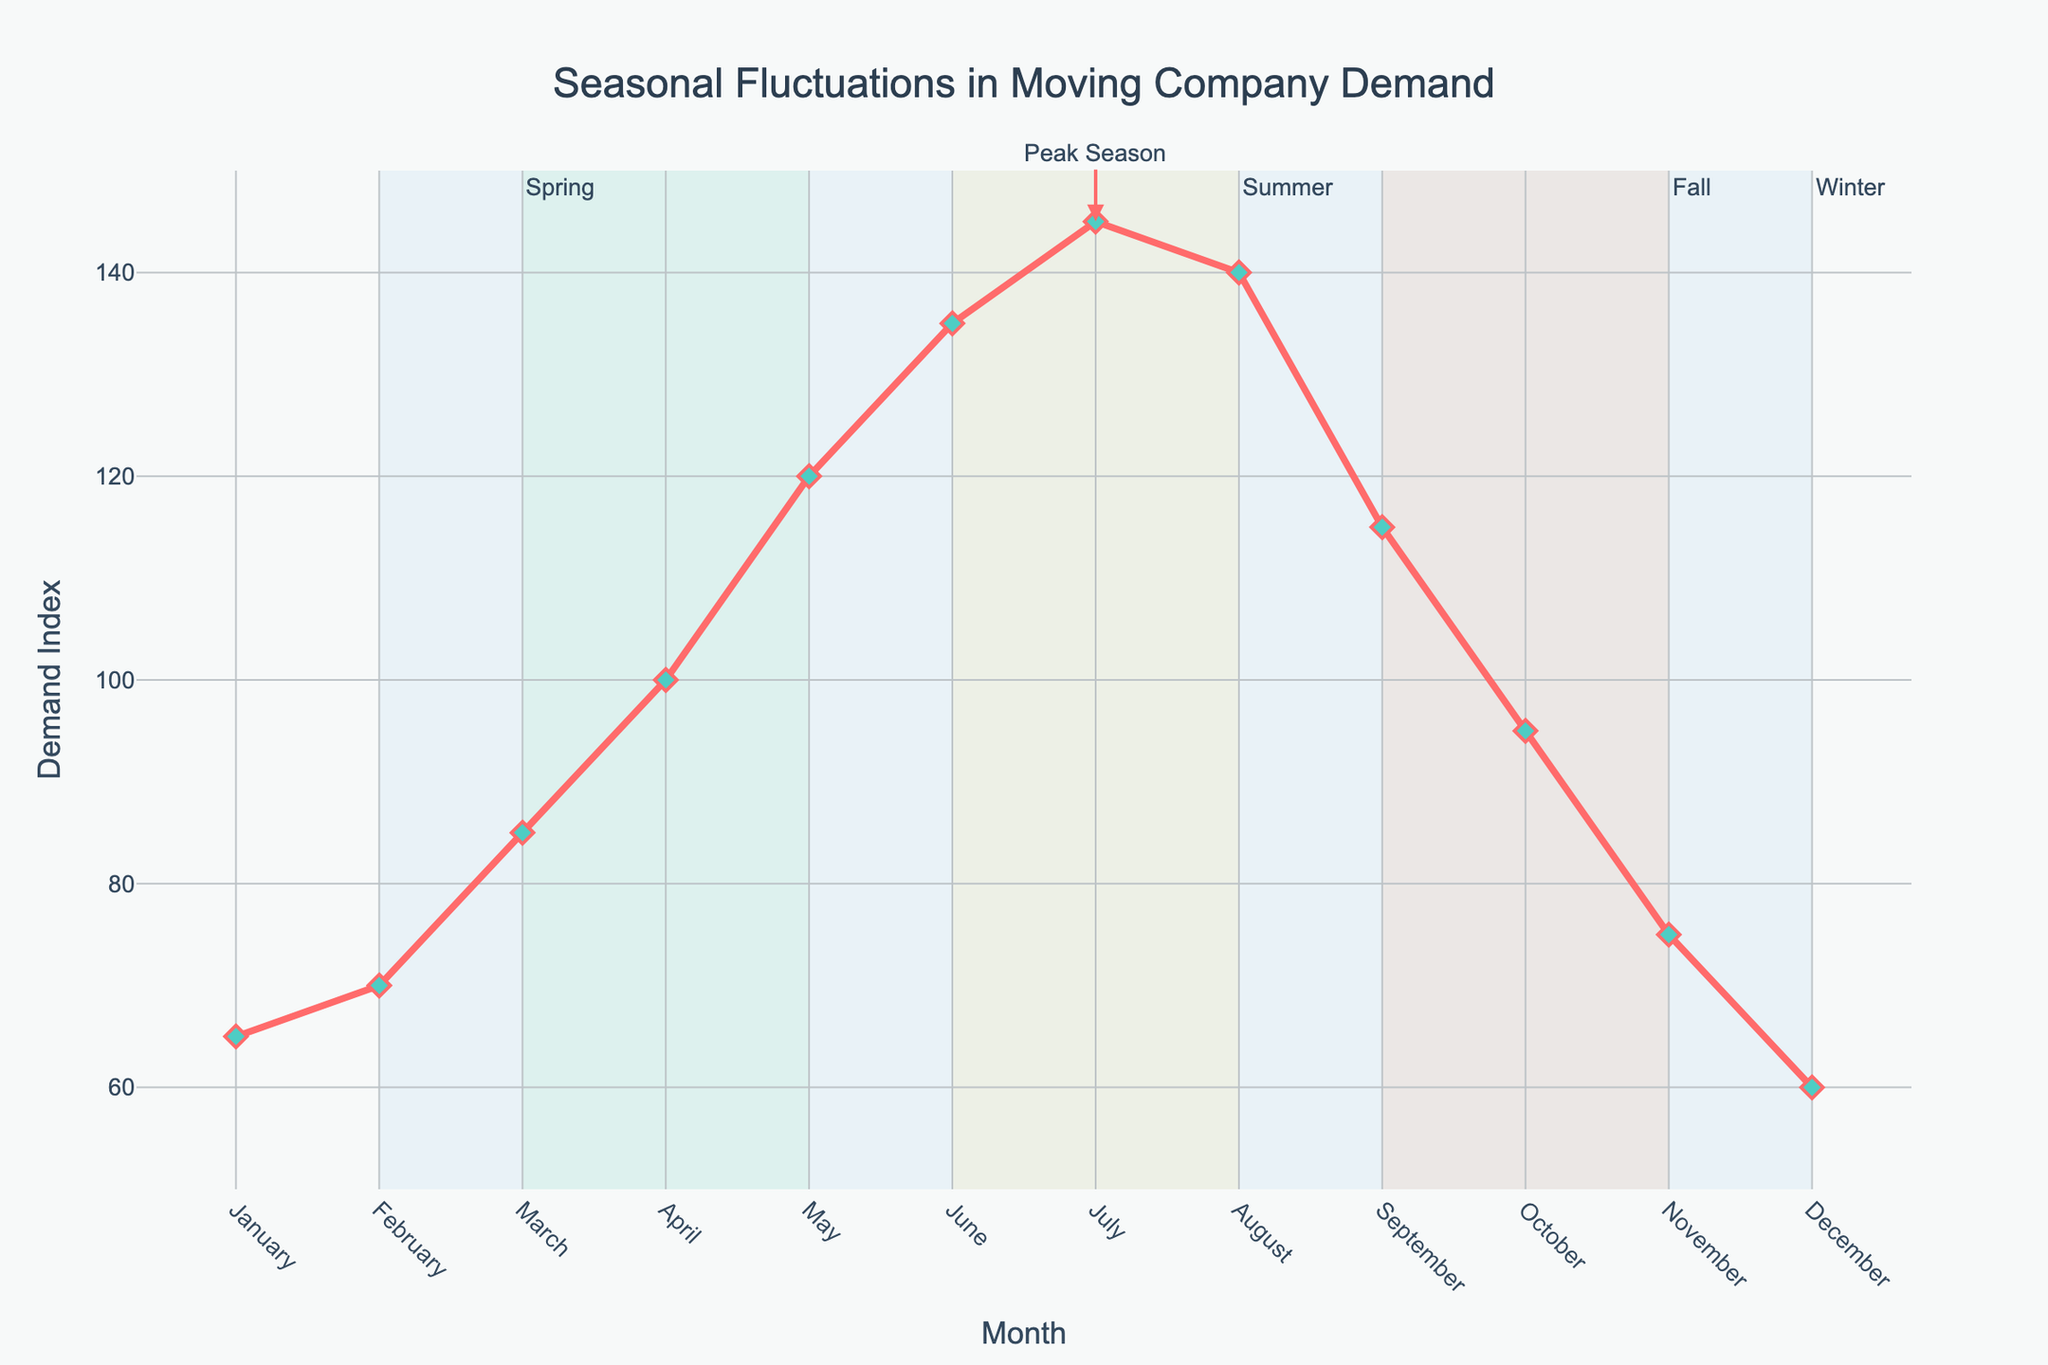What's the peak month for moving company demand? The peak month is indicated visually by the highest point on the line chart. In this case, the highest Demand Index (145) occurs in July.
Answer: July How does the demand in July compare to the demand in December? To compare the demands, subtract the Demand Index of December from that of July. July has a Demand Index of 145, and December has a Demand Index of 60. 145 - 60 = 85.
Answer: 85 What is the average demand index for the summer months (June, July, August)? To find the average demand for the summer months, sum the Demand Indices for June, July, and August and divide by 3. \( (135 + 145 + 140) / 3 = 420 / 3 = 140 \).
Answer: 140 During which season does the demand taper off after the peak? After the peak in July (summer), the demand starts decreasing consistently in the fall season, where values are 115 for September, 95 for October, and 75 for November.
Answer: Fall What is the total increase in demand from January to June? Calculate the difference between the Demand Index in June and January, 135 for June and 65 for January. \( 135 - 65 = 70 \).
Answer: 70 Between which two consecutive months is the highest increase in demand observed? Observe the largest vertical leap between consecutive months on the chart. The largest increase is from April to May, where the Demand Index jumps from 100 to 120. \( 120 - 100 = 20 \).
Answer: April to May Which season has the lowest average demand index? Calculate the average Demand Index for each season and compare them. Winter: \( (60 + 65 + 70) / 3 = 65 \), Spring: \( (85 + 100 + 120) / 3 = 101.67 \), Summer: \( (135 + 145 + 140) / 3 = 140 \), Fall: \( (115 + 95 + 75) / 3 = 95 \). The lowest average is in Winter.
Answer: Winter How does the demand in February compare with that in November? Subtract the Demand Index of November (75) from February (70). \( 70 - 75 = -5 \). This results in a negative value indicating a decrease.
Answer: -5 